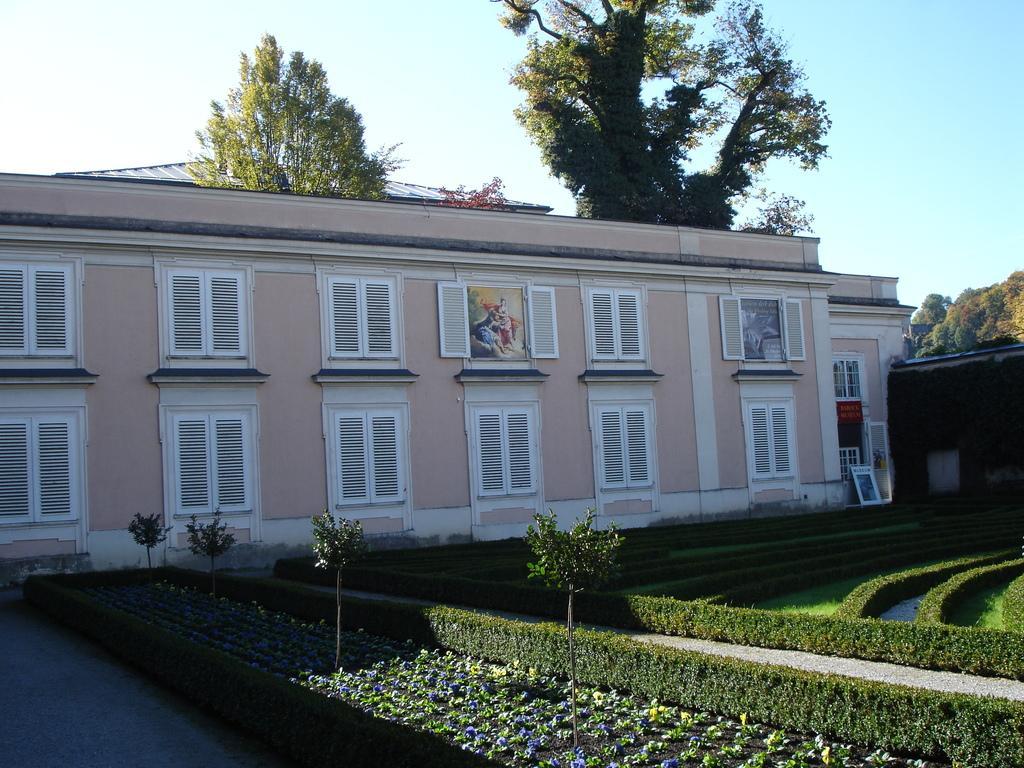Describe this image in one or two sentences. This picture is clicked outside. In the foreground we can see the grass, plants and flowers. In the center we can see the building and the windows of the building. In the background we can see the sky and the trees. 